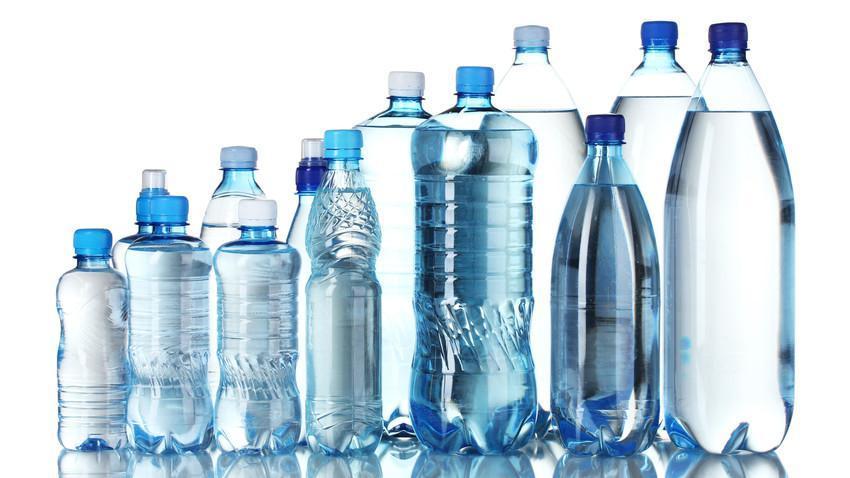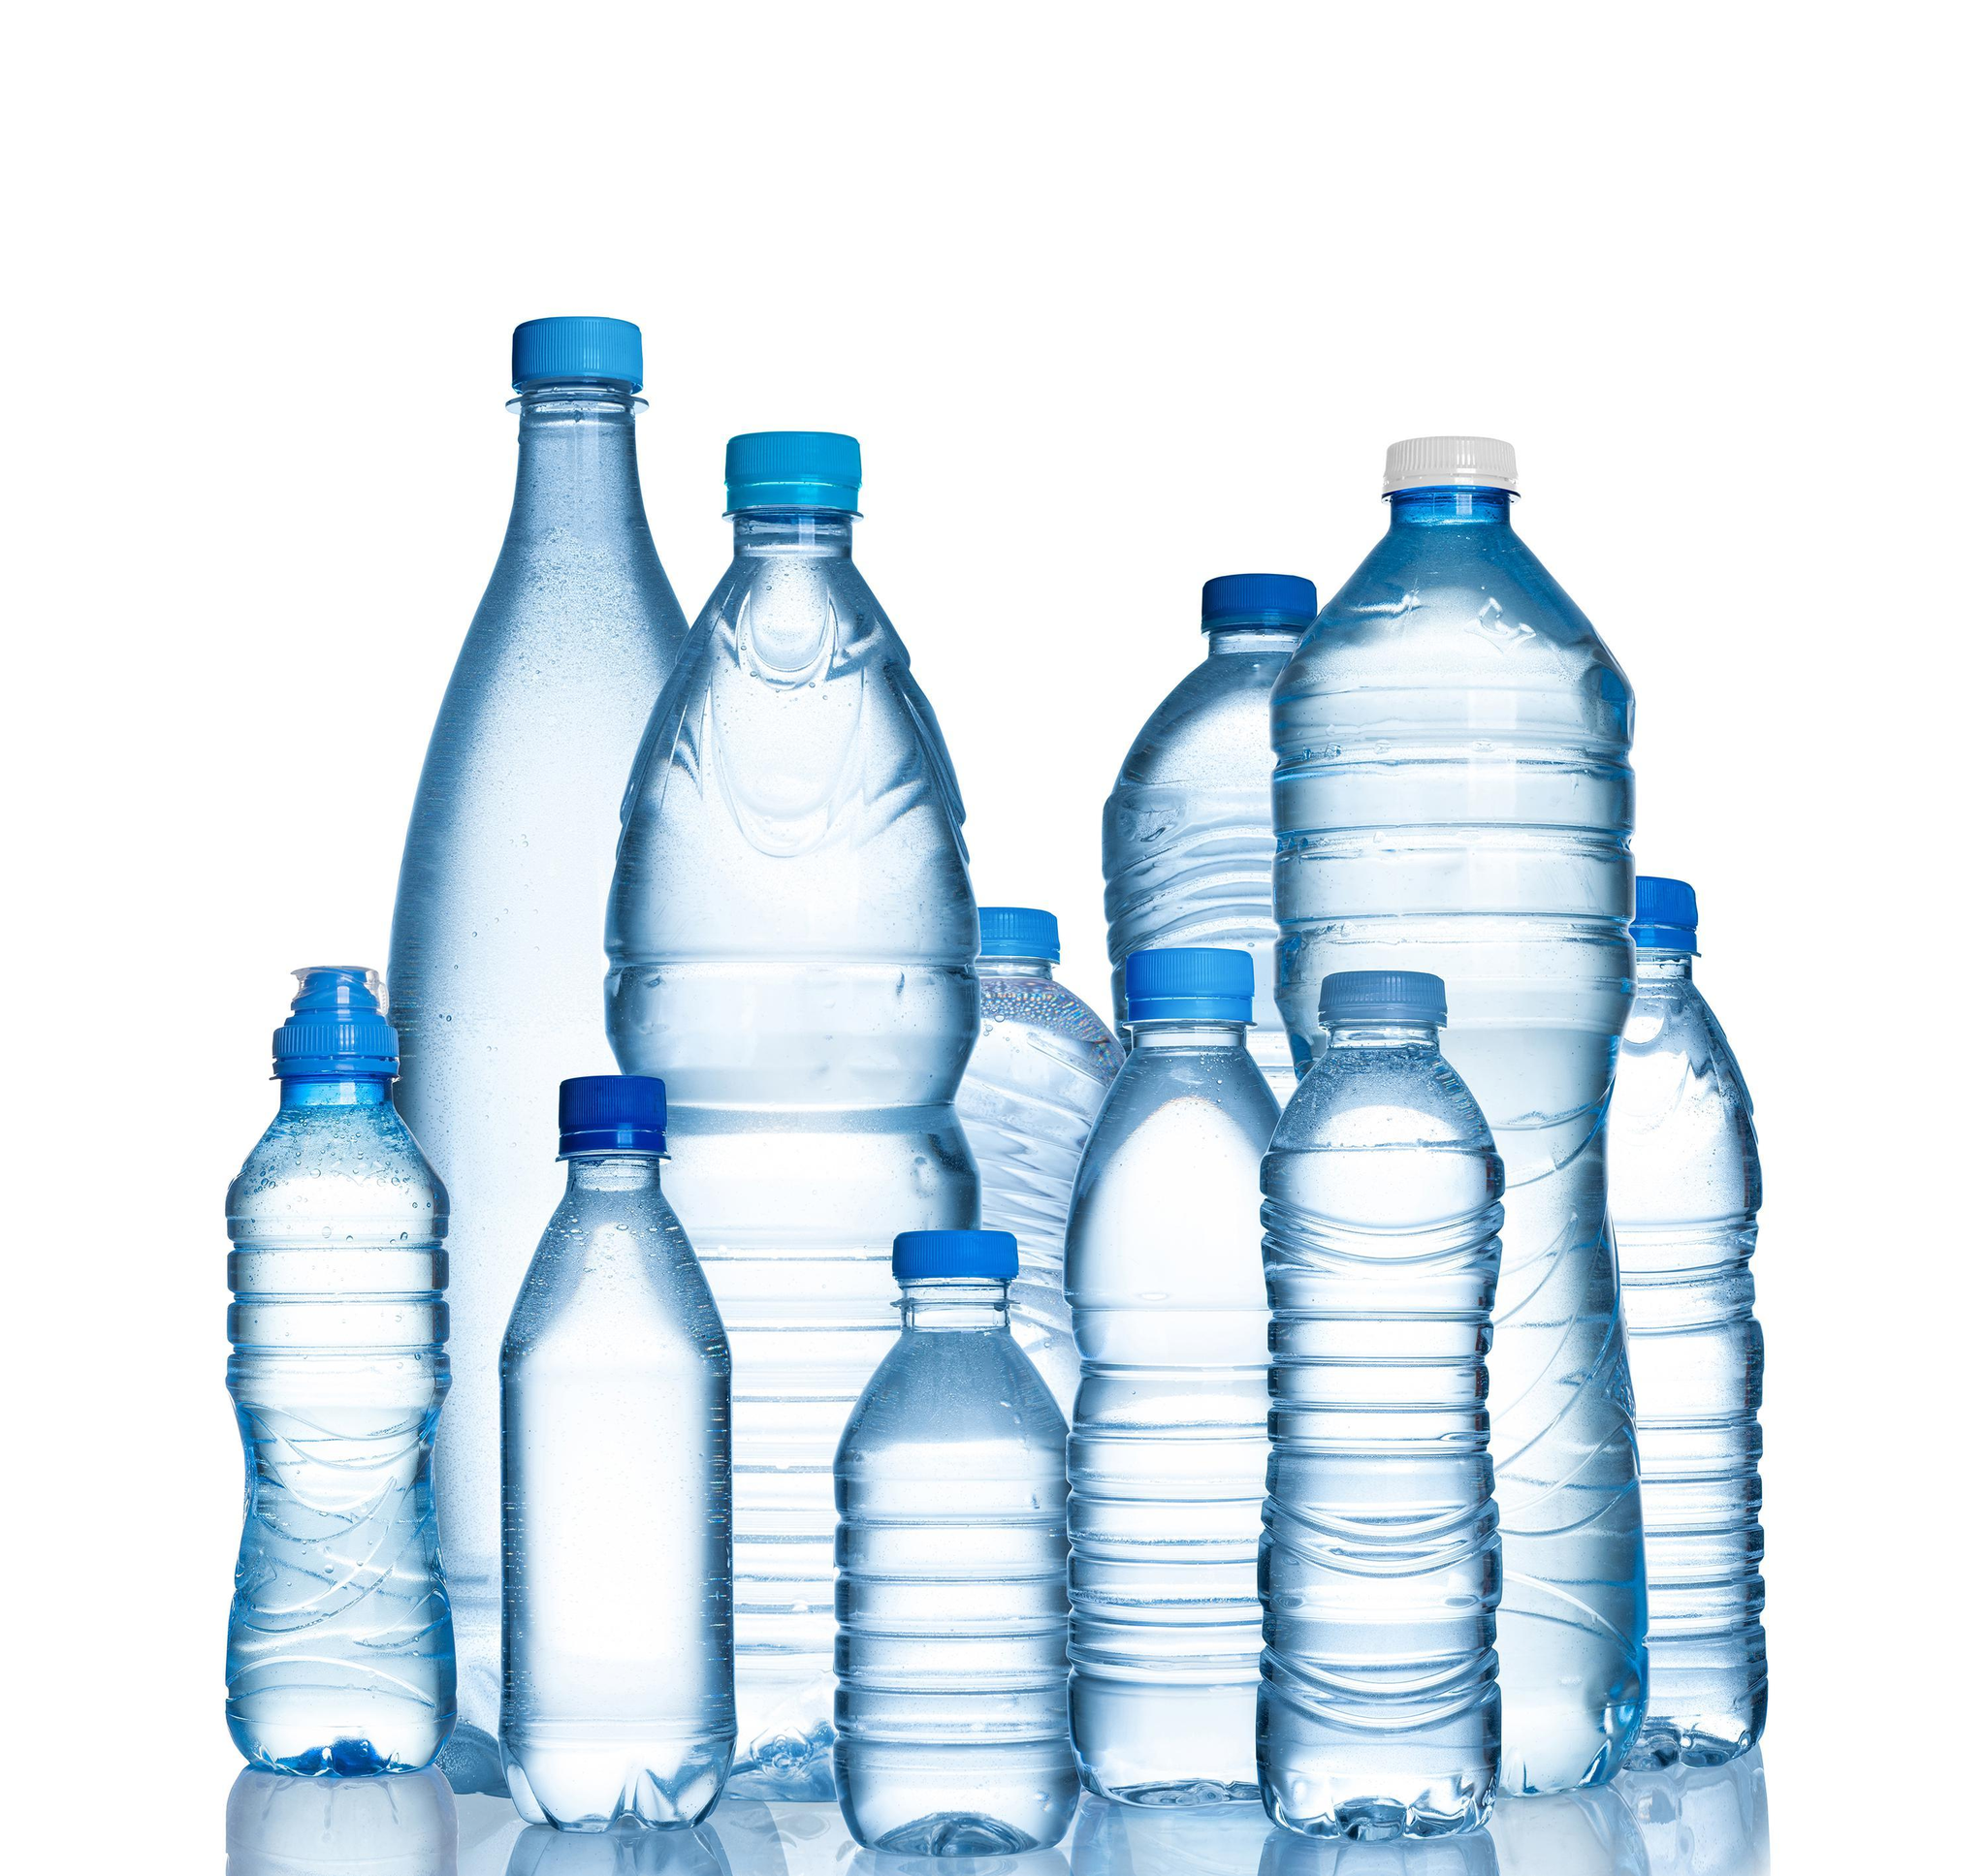The first image is the image on the left, the second image is the image on the right. Analyze the images presented: Is the assertion "Each image shows at least five water bottles arranged in an overlapping formation." valid? Answer yes or no. Yes. The first image is the image on the left, the second image is the image on the right. For the images displayed, is the sentence "In the image on the left, all of the bottle are the same size." factually correct? Answer yes or no. No. 